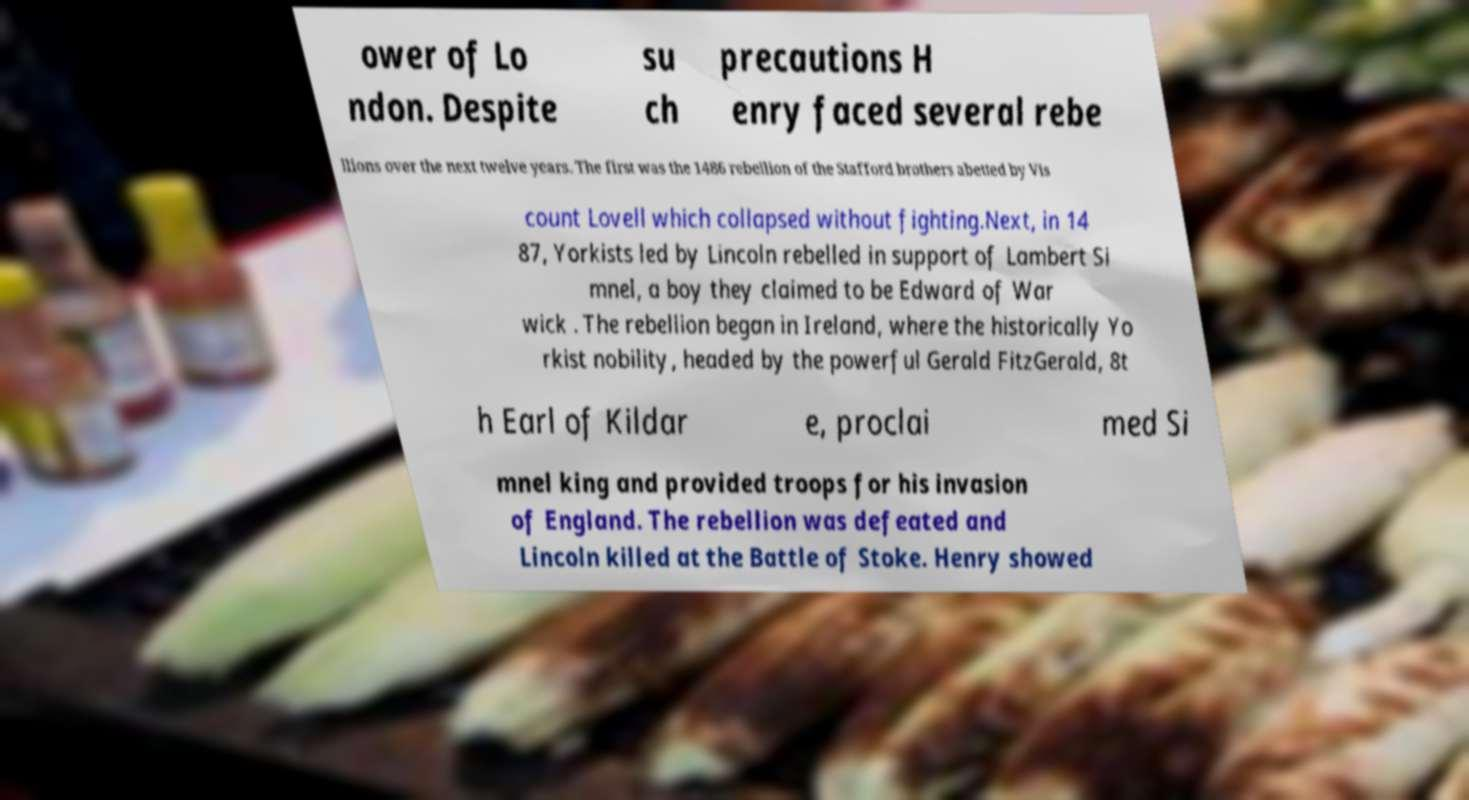Can you accurately transcribe the text from the provided image for me? ower of Lo ndon. Despite su ch precautions H enry faced several rebe llions over the next twelve years. The first was the 1486 rebellion of the Stafford brothers abetted by Vis count Lovell which collapsed without fighting.Next, in 14 87, Yorkists led by Lincoln rebelled in support of Lambert Si mnel, a boy they claimed to be Edward of War wick . The rebellion began in Ireland, where the historically Yo rkist nobility, headed by the powerful Gerald FitzGerald, 8t h Earl of Kildar e, proclai med Si mnel king and provided troops for his invasion of England. The rebellion was defeated and Lincoln killed at the Battle of Stoke. Henry showed 